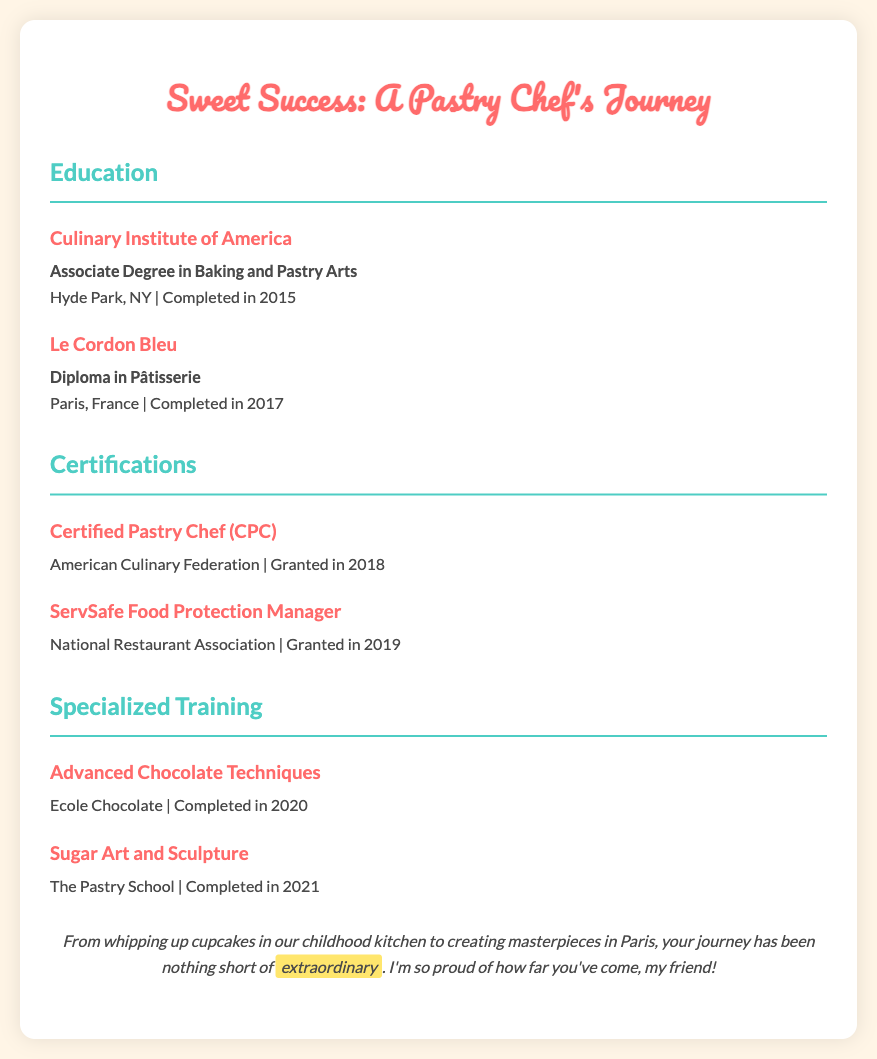What degree did the chef earn at the Culinary Institute of America? The Culinary Institute of America awarded the chef an Associate Degree in Baking and Pastry Arts.
Answer: Associate Degree in Baking and Pastry Arts When did the chef complete their diploma at Le Cordon Bleu? The diploma in Pâtisserie was completed in 2017.
Answer: 2017 What certification was granted in 2018? The chef received the Certified Pastry Chef (CPC) certification in 2018.
Answer: Certified Pastry Chef (CPC) Which organization issued the ServSafe Food Protection Manager certification? The National Restaurant Association is the organization that granted the certification.
Answer: National Restaurant Association What specialized training did the chef complete in 2021? The chef completed training in Sugar Art and Sculpture in 2021.
Answer: Sugar Art and Sculpture How many years passed between the completion of the Associate Degree and the diploma in Pâtisserie? The chef completed the Associate Degree in 2015 and the diploma in 2017, totaling a gap of 2 years.
Answer: 2 years Which training program focuses on chocolate techniques? The Advanced Chocolate Techniques training is the program that focuses on chocolate techniques.
Answer: Advanced Chocolate Techniques What is the chef’s proudest accomplishment mentioned in the document? The document mentions the extraordinary journey of the chef, from childhood baking to creating masterpieces in Paris.
Answer: extraordinary 